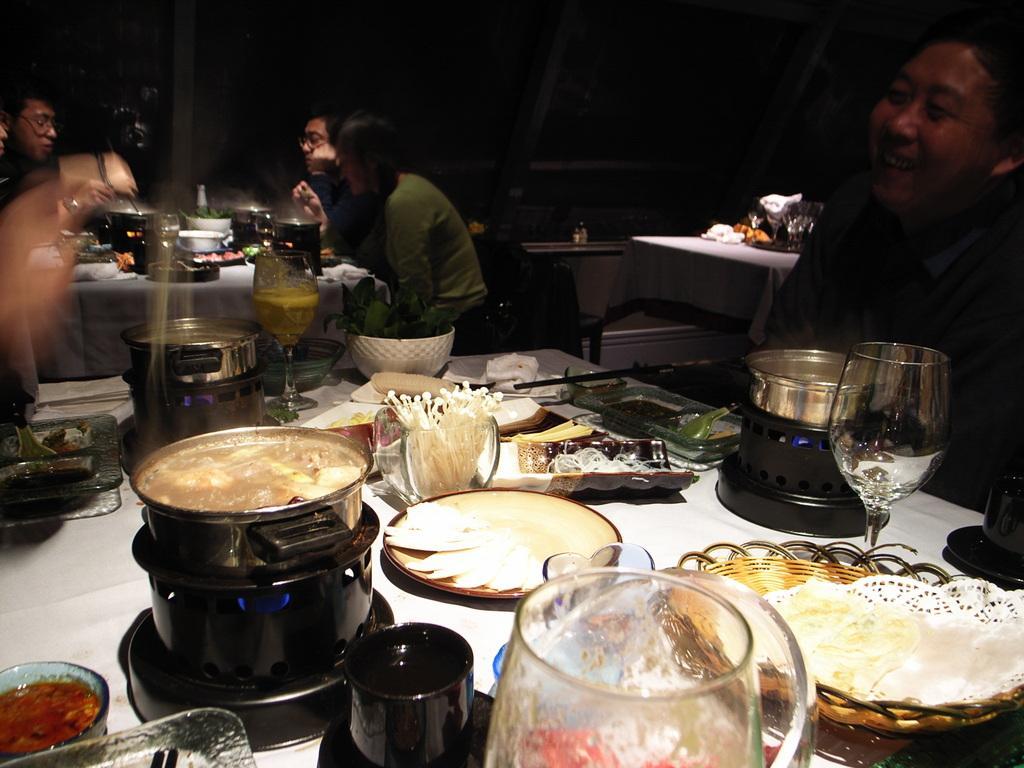Describe this image in one or two sentences. In this image we can see a table, and above the table we can see food materials tea cup glass and food beverages. On the right side, we can see a man sitting near the table and in the left side, we can see another table and another man. In the middle back side two people sitting and having food. 